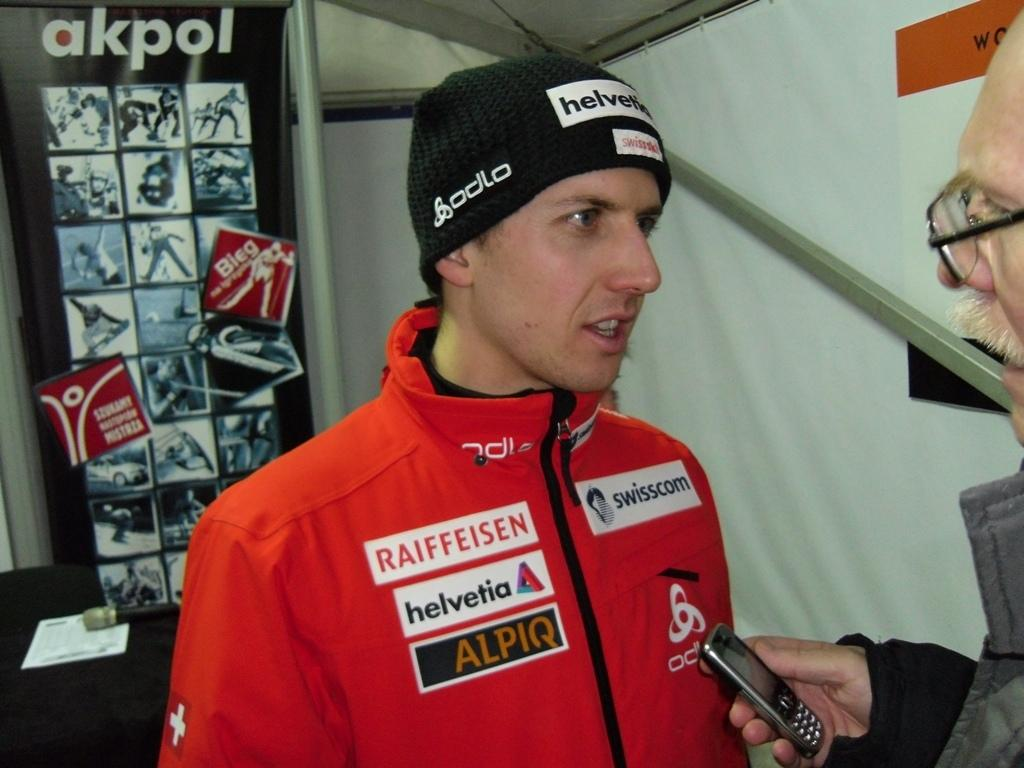<image>
Write a terse but informative summary of the picture. a man that had a helvetia jacket on and is talking 